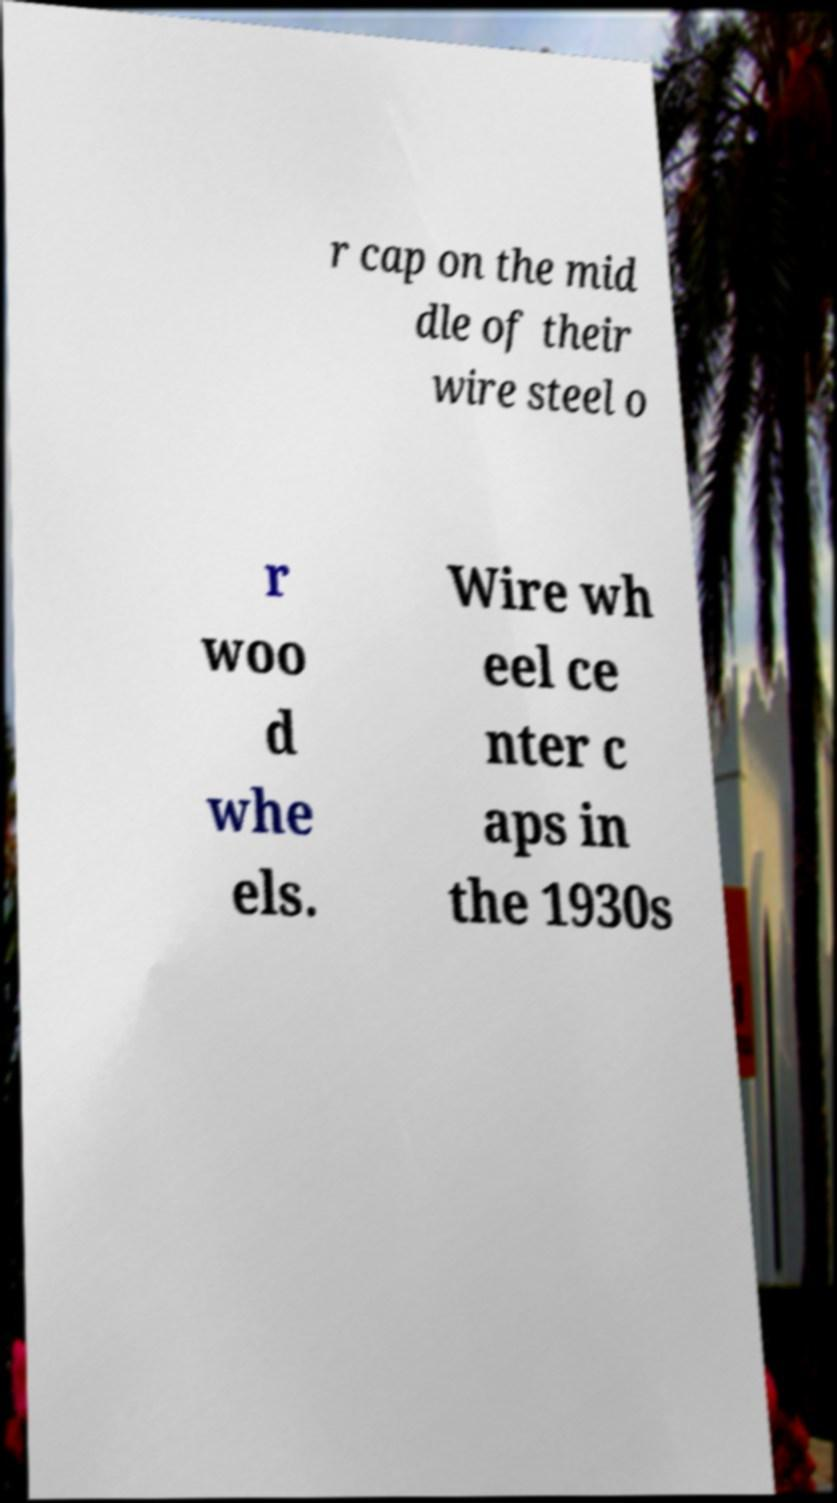Could you assist in decoding the text presented in this image and type it out clearly? r cap on the mid dle of their wire steel o r woo d whe els. Wire wh eel ce nter c aps in the 1930s 